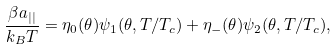<formula> <loc_0><loc_0><loc_500><loc_500>\frac { \beta a _ { | | } } { k _ { B } T } = \eta _ { 0 } ( \theta ) \psi _ { 1 } ( \theta , T / T _ { c } ) + \eta _ { - } ( \theta ) \psi _ { 2 } ( \theta , T / T _ { c } ) , \\</formula> 